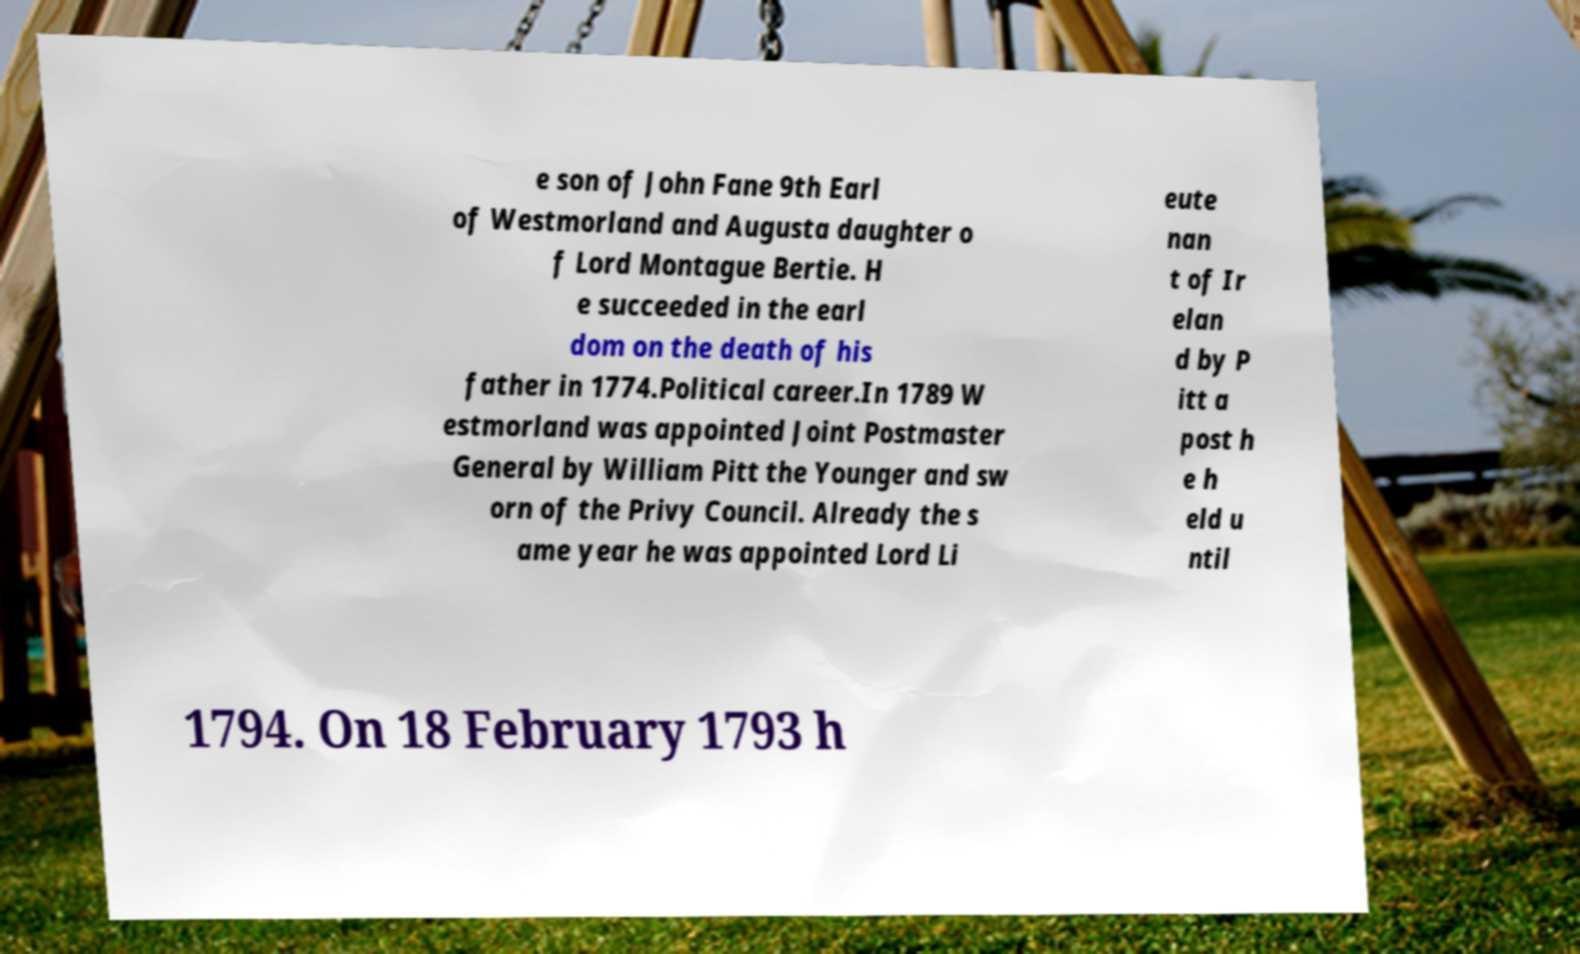Can you accurately transcribe the text from the provided image for me? e son of John Fane 9th Earl of Westmorland and Augusta daughter o f Lord Montague Bertie. H e succeeded in the earl dom on the death of his father in 1774.Political career.In 1789 W estmorland was appointed Joint Postmaster General by William Pitt the Younger and sw orn of the Privy Council. Already the s ame year he was appointed Lord Li eute nan t of Ir elan d by P itt a post h e h eld u ntil 1794. On 18 February 1793 h 